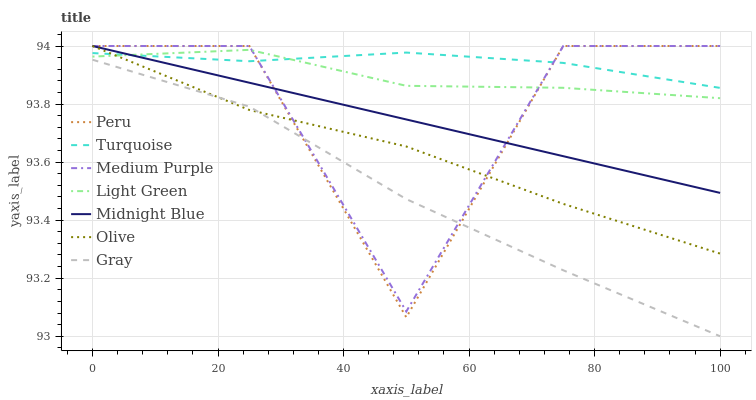Does Peru have the minimum area under the curve?
Answer yes or no. No. Does Peru have the maximum area under the curve?
Answer yes or no. No. Is Turquoise the smoothest?
Answer yes or no. No. Is Turquoise the roughest?
Answer yes or no. No. Does Peru have the lowest value?
Answer yes or no. No. Does Turquoise have the highest value?
Answer yes or no. No. Is Gray less than Turquoise?
Answer yes or no. Yes. Is Midnight Blue greater than Gray?
Answer yes or no. Yes. Does Gray intersect Turquoise?
Answer yes or no. No. 